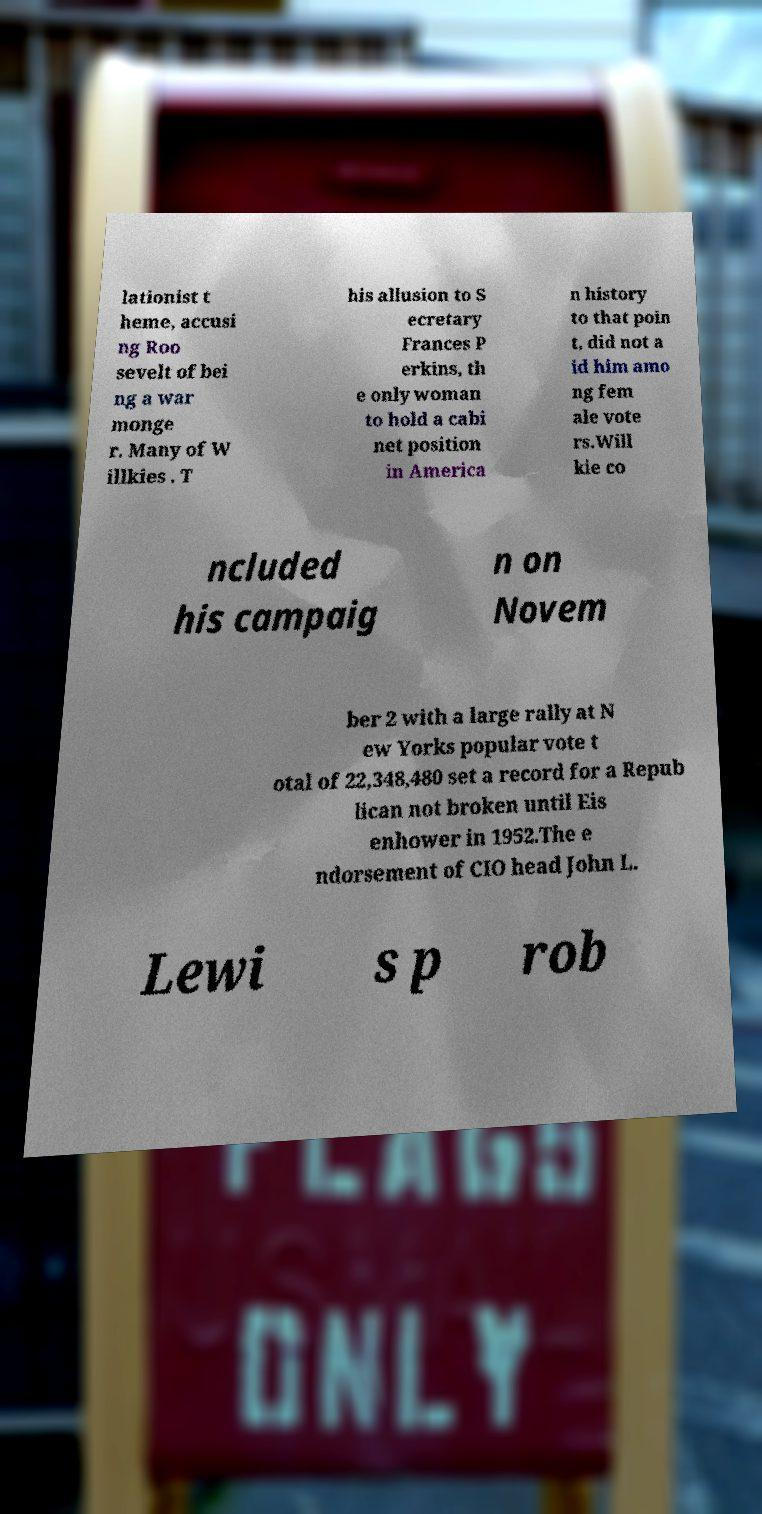Could you assist in decoding the text presented in this image and type it out clearly? lationist t heme, accusi ng Roo sevelt of bei ng a war monge r. Many of W illkies . T his allusion to S ecretary Frances P erkins, th e only woman to hold a cabi net position in America n history to that poin t, did not a id him amo ng fem ale vote rs.Will kie co ncluded his campaig n on Novem ber 2 with a large rally at N ew Yorks popular vote t otal of 22,348,480 set a record for a Repub lican not broken until Eis enhower in 1952.The e ndorsement of CIO head John L. Lewi s p rob 